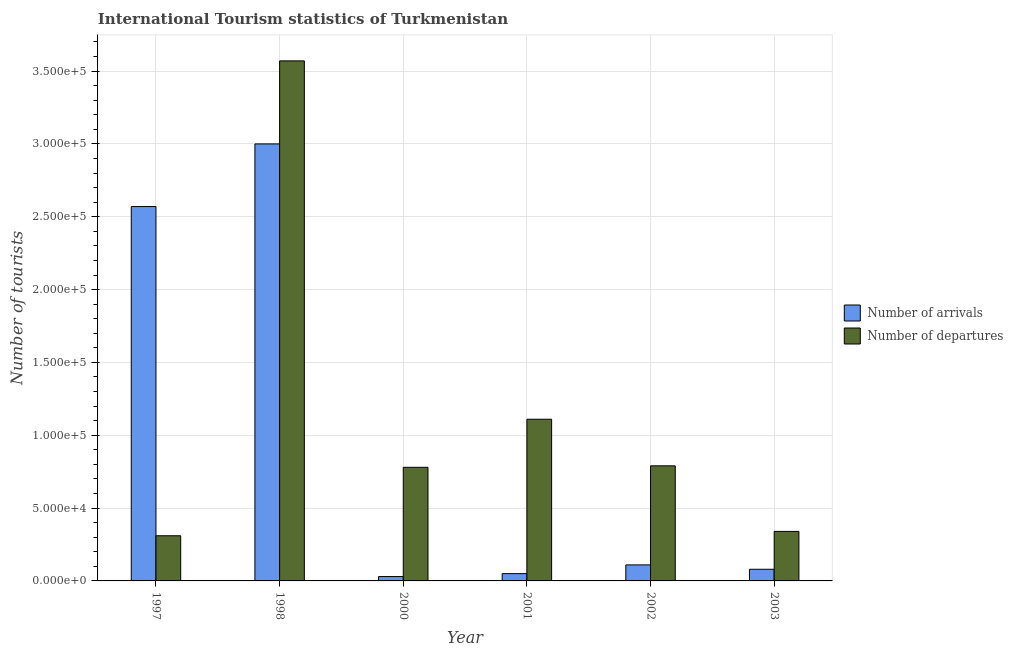How many groups of bars are there?
Your answer should be very brief. 6. Are the number of bars per tick equal to the number of legend labels?
Your answer should be compact. Yes. Are the number of bars on each tick of the X-axis equal?
Ensure brevity in your answer.  Yes. How many bars are there on the 3rd tick from the right?
Ensure brevity in your answer.  2. What is the label of the 3rd group of bars from the left?
Ensure brevity in your answer.  2000. In how many cases, is the number of bars for a given year not equal to the number of legend labels?
Give a very brief answer. 0. What is the number of tourist arrivals in 2002?
Make the answer very short. 1.10e+04. Across all years, what is the maximum number of tourist arrivals?
Offer a terse response. 3.00e+05. Across all years, what is the minimum number of tourist arrivals?
Keep it short and to the point. 3000. In which year was the number of tourist arrivals maximum?
Provide a succinct answer. 1998. What is the total number of tourist arrivals in the graph?
Offer a terse response. 5.84e+05. What is the difference between the number of tourist departures in 1997 and that in 2003?
Offer a terse response. -3000. What is the difference between the number of tourist departures in 1998 and the number of tourist arrivals in 2002?
Provide a succinct answer. 2.78e+05. What is the average number of tourist departures per year?
Offer a very short reply. 1.15e+05. In how many years, is the number of tourist departures greater than 270000?
Keep it short and to the point. 1. What is the ratio of the number of tourist arrivals in 1997 to that in 1998?
Your answer should be very brief. 0.86. Is the number of tourist departures in 1997 less than that in 1998?
Make the answer very short. Yes. Is the difference between the number of tourist arrivals in 2001 and 2002 greater than the difference between the number of tourist departures in 2001 and 2002?
Your answer should be compact. No. What is the difference between the highest and the second highest number of tourist departures?
Give a very brief answer. 2.46e+05. What is the difference between the highest and the lowest number of tourist arrivals?
Provide a succinct answer. 2.97e+05. In how many years, is the number of tourist departures greater than the average number of tourist departures taken over all years?
Your answer should be very brief. 1. Is the sum of the number of tourist arrivals in 2000 and 2001 greater than the maximum number of tourist departures across all years?
Provide a short and direct response. No. What does the 2nd bar from the left in 2002 represents?
Offer a terse response. Number of departures. What does the 2nd bar from the right in 2003 represents?
Offer a very short reply. Number of arrivals. Are all the bars in the graph horizontal?
Your answer should be compact. No. How many years are there in the graph?
Offer a terse response. 6. What is the difference between two consecutive major ticks on the Y-axis?
Make the answer very short. 5.00e+04. Does the graph contain grids?
Your answer should be compact. Yes. Where does the legend appear in the graph?
Provide a short and direct response. Center right. How many legend labels are there?
Your answer should be very brief. 2. How are the legend labels stacked?
Your answer should be compact. Vertical. What is the title of the graph?
Ensure brevity in your answer.  International Tourism statistics of Turkmenistan. Does "Register a property" appear as one of the legend labels in the graph?
Make the answer very short. No. What is the label or title of the X-axis?
Ensure brevity in your answer.  Year. What is the label or title of the Y-axis?
Your answer should be compact. Number of tourists. What is the Number of tourists in Number of arrivals in 1997?
Provide a short and direct response. 2.57e+05. What is the Number of tourists in Number of departures in 1997?
Keep it short and to the point. 3.10e+04. What is the Number of tourists in Number of arrivals in 1998?
Ensure brevity in your answer.  3.00e+05. What is the Number of tourists in Number of departures in 1998?
Offer a very short reply. 3.57e+05. What is the Number of tourists in Number of arrivals in 2000?
Your answer should be compact. 3000. What is the Number of tourists in Number of departures in 2000?
Your answer should be compact. 7.80e+04. What is the Number of tourists of Number of arrivals in 2001?
Your answer should be compact. 5000. What is the Number of tourists of Number of departures in 2001?
Your answer should be compact. 1.11e+05. What is the Number of tourists of Number of arrivals in 2002?
Provide a short and direct response. 1.10e+04. What is the Number of tourists in Number of departures in 2002?
Your answer should be very brief. 7.90e+04. What is the Number of tourists in Number of arrivals in 2003?
Offer a very short reply. 8000. What is the Number of tourists in Number of departures in 2003?
Your response must be concise. 3.40e+04. Across all years, what is the maximum Number of tourists in Number of departures?
Give a very brief answer. 3.57e+05. Across all years, what is the minimum Number of tourists of Number of arrivals?
Keep it short and to the point. 3000. Across all years, what is the minimum Number of tourists of Number of departures?
Offer a terse response. 3.10e+04. What is the total Number of tourists in Number of arrivals in the graph?
Your answer should be compact. 5.84e+05. What is the total Number of tourists in Number of departures in the graph?
Offer a terse response. 6.90e+05. What is the difference between the Number of tourists of Number of arrivals in 1997 and that in 1998?
Give a very brief answer. -4.30e+04. What is the difference between the Number of tourists of Number of departures in 1997 and that in 1998?
Provide a succinct answer. -3.26e+05. What is the difference between the Number of tourists of Number of arrivals in 1997 and that in 2000?
Your answer should be compact. 2.54e+05. What is the difference between the Number of tourists in Number of departures in 1997 and that in 2000?
Offer a very short reply. -4.70e+04. What is the difference between the Number of tourists of Number of arrivals in 1997 and that in 2001?
Offer a very short reply. 2.52e+05. What is the difference between the Number of tourists of Number of arrivals in 1997 and that in 2002?
Your response must be concise. 2.46e+05. What is the difference between the Number of tourists in Number of departures in 1997 and that in 2002?
Give a very brief answer. -4.80e+04. What is the difference between the Number of tourists of Number of arrivals in 1997 and that in 2003?
Provide a succinct answer. 2.49e+05. What is the difference between the Number of tourists in Number of departures in 1997 and that in 2003?
Provide a succinct answer. -3000. What is the difference between the Number of tourists of Number of arrivals in 1998 and that in 2000?
Offer a terse response. 2.97e+05. What is the difference between the Number of tourists of Number of departures in 1998 and that in 2000?
Offer a terse response. 2.79e+05. What is the difference between the Number of tourists of Number of arrivals in 1998 and that in 2001?
Offer a terse response. 2.95e+05. What is the difference between the Number of tourists of Number of departures in 1998 and that in 2001?
Offer a very short reply. 2.46e+05. What is the difference between the Number of tourists in Number of arrivals in 1998 and that in 2002?
Offer a terse response. 2.89e+05. What is the difference between the Number of tourists of Number of departures in 1998 and that in 2002?
Keep it short and to the point. 2.78e+05. What is the difference between the Number of tourists in Number of arrivals in 1998 and that in 2003?
Ensure brevity in your answer.  2.92e+05. What is the difference between the Number of tourists of Number of departures in 1998 and that in 2003?
Provide a short and direct response. 3.23e+05. What is the difference between the Number of tourists in Number of arrivals in 2000 and that in 2001?
Ensure brevity in your answer.  -2000. What is the difference between the Number of tourists of Number of departures in 2000 and that in 2001?
Offer a terse response. -3.30e+04. What is the difference between the Number of tourists in Number of arrivals in 2000 and that in 2002?
Make the answer very short. -8000. What is the difference between the Number of tourists in Number of departures in 2000 and that in 2002?
Your answer should be compact. -1000. What is the difference between the Number of tourists in Number of arrivals in 2000 and that in 2003?
Offer a terse response. -5000. What is the difference between the Number of tourists of Number of departures in 2000 and that in 2003?
Keep it short and to the point. 4.40e+04. What is the difference between the Number of tourists in Number of arrivals in 2001 and that in 2002?
Make the answer very short. -6000. What is the difference between the Number of tourists in Number of departures in 2001 and that in 2002?
Your response must be concise. 3.20e+04. What is the difference between the Number of tourists of Number of arrivals in 2001 and that in 2003?
Offer a terse response. -3000. What is the difference between the Number of tourists of Number of departures in 2001 and that in 2003?
Make the answer very short. 7.70e+04. What is the difference between the Number of tourists of Number of arrivals in 2002 and that in 2003?
Make the answer very short. 3000. What is the difference between the Number of tourists in Number of departures in 2002 and that in 2003?
Offer a terse response. 4.50e+04. What is the difference between the Number of tourists of Number of arrivals in 1997 and the Number of tourists of Number of departures in 1998?
Provide a short and direct response. -1.00e+05. What is the difference between the Number of tourists of Number of arrivals in 1997 and the Number of tourists of Number of departures in 2000?
Provide a succinct answer. 1.79e+05. What is the difference between the Number of tourists in Number of arrivals in 1997 and the Number of tourists in Number of departures in 2001?
Give a very brief answer. 1.46e+05. What is the difference between the Number of tourists of Number of arrivals in 1997 and the Number of tourists of Number of departures in 2002?
Your answer should be compact. 1.78e+05. What is the difference between the Number of tourists of Number of arrivals in 1997 and the Number of tourists of Number of departures in 2003?
Your response must be concise. 2.23e+05. What is the difference between the Number of tourists of Number of arrivals in 1998 and the Number of tourists of Number of departures in 2000?
Your answer should be very brief. 2.22e+05. What is the difference between the Number of tourists in Number of arrivals in 1998 and the Number of tourists in Number of departures in 2001?
Make the answer very short. 1.89e+05. What is the difference between the Number of tourists of Number of arrivals in 1998 and the Number of tourists of Number of departures in 2002?
Your response must be concise. 2.21e+05. What is the difference between the Number of tourists in Number of arrivals in 1998 and the Number of tourists in Number of departures in 2003?
Your answer should be compact. 2.66e+05. What is the difference between the Number of tourists of Number of arrivals in 2000 and the Number of tourists of Number of departures in 2001?
Your answer should be compact. -1.08e+05. What is the difference between the Number of tourists in Number of arrivals in 2000 and the Number of tourists in Number of departures in 2002?
Your response must be concise. -7.60e+04. What is the difference between the Number of tourists in Number of arrivals in 2000 and the Number of tourists in Number of departures in 2003?
Provide a succinct answer. -3.10e+04. What is the difference between the Number of tourists of Number of arrivals in 2001 and the Number of tourists of Number of departures in 2002?
Ensure brevity in your answer.  -7.40e+04. What is the difference between the Number of tourists in Number of arrivals in 2001 and the Number of tourists in Number of departures in 2003?
Offer a terse response. -2.90e+04. What is the difference between the Number of tourists in Number of arrivals in 2002 and the Number of tourists in Number of departures in 2003?
Offer a very short reply. -2.30e+04. What is the average Number of tourists in Number of arrivals per year?
Your answer should be compact. 9.73e+04. What is the average Number of tourists in Number of departures per year?
Provide a succinct answer. 1.15e+05. In the year 1997, what is the difference between the Number of tourists in Number of arrivals and Number of tourists in Number of departures?
Offer a terse response. 2.26e+05. In the year 1998, what is the difference between the Number of tourists in Number of arrivals and Number of tourists in Number of departures?
Provide a succinct answer. -5.70e+04. In the year 2000, what is the difference between the Number of tourists in Number of arrivals and Number of tourists in Number of departures?
Make the answer very short. -7.50e+04. In the year 2001, what is the difference between the Number of tourists of Number of arrivals and Number of tourists of Number of departures?
Give a very brief answer. -1.06e+05. In the year 2002, what is the difference between the Number of tourists in Number of arrivals and Number of tourists in Number of departures?
Offer a very short reply. -6.80e+04. In the year 2003, what is the difference between the Number of tourists in Number of arrivals and Number of tourists in Number of departures?
Give a very brief answer. -2.60e+04. What is the ratio of the Number of tourists of Number of arrivals in 1997 to that in 1998?
Offer a very short reply. 0.86. What is the ratio of the Number of tourists of Number of departures in 1997 to that in 1998?
Your response must be concise. 0.09. What is the ratio of the Number of tourists in Number of arrivals in 1997 to that in 2000?
Your answer should be very brief. 85.67. What is the ratio of the Number of tourists in Number of departures in 1997 to that in 2000?
Give a very brief answer. 0.4. What is the ratio of the Number of tourists in Number of arrivals in 1997 to that in 2001?
Your answer should be compact. 51.4. What is the ratio of the Number of tourists of Number of departures in 1997 to that in 2001?
Offer a very short reply. 0.28. What is the ratio of the Number of tourists in Number of arrivals in 1997 to that in 2002?
Offer a very short reply. 23.36. What is the ratio of the Number of tourists of Number of departures in 1997 to that in 2002?
Provide a succinct answer. 0.39. What is the ratio of the Number of tourists in Number of arrivals in 1997 to that in 2003?
Your answer should be compact. 32.12. What is the ratio of the Number of tourists of Number of departures in 1997 to that in 2003?
Provide a succinct answer. 0.91. What is the ratio of the Number of tourists of Number of arrivals in 1998 to that in 2000?
Your answer should be compact. 100. What is the ratio of the Number of tourists in Number of departures in 1998 to that in 2000?
Your answer should be very brief. 4.58. What is the ratio of the Number of tourists in Number of arrivals in 1998 to that in 2001?
Provide a short and direct response. 60. What is the ratio of the Number of tourists of Number of departures in 1998 to that in 2001?
Make the answer very short. 3.22. What is the ratio of the Number of tourists in Number of arrivals in 1998 to that in 2002?
Your response must be concise. 27.27. What is the ratio of the Number of tourists in Number of departures in 1998 to that in 2002?
Your response must be concise. 4.52. What is the ratio of the Number of tourists of Number of arrivals in 1998 to that in 2003?
Keep it short and to the point. 37.5. What is the ratio of the Number of tourists of Number of departures in 2000 to that in 2001?
Give a very brief answer. 0.7. What is the ratio of the Number of tourists of Number of arrivals in 2000 to that in 2002?
Give a very brief answer. 0.27. What is the ratio of the Number of tourists of Number of departures in 2000 to that in 2002?
Keep it short and to the point. 0.99. What is the ratio of the Number of tourists of Number of arrivals in 2000 to that in 2003?
Offer a very short reply. 0.38. What is the ratio of the Number of tourists of Number of departures in 2000 to that in 2003?
Make the answer very short. 2.29. What is the ratio of the Number of tourists of Number of arrivals in 2001 to that in 2002?
Your answer should be compact. 0.45. What is the ratio of the Number of tourists of Number of departures in 2001 to that in 2002?
Your answer should be very brief. 1.41. What is the ratio of the Number of tourists in Number of departures in 2001 to that in 2003?
Provide a short and direct response. 3.26. What is the ratio of the Number of tourists of Number of arrivals in 2002 to that in 2003?
Ensure brevity in your answer.  1.38. What is the ratio of the Number of tourists in Number of departures in 2002 to that in 2003?
Keep it short and to the point. 2.32. What is the difference between the highest and the second highest Number of tourists in Number of arrivals?
Provide a succinct answer. 4.30e+04. What is the difference between the highest and the second highest Number of tourists in Number of departures?
Provide a succinct answer. 2.46e+05. What is the difference between the highest and the lowest Number of tourists of Number of arrivals?
Keep it short and to the point. 2.97e+05. What is the difference between the highest and the lowest Number of tourists of Number of departures?
Your answer should be very brief. 3.26e+05. 